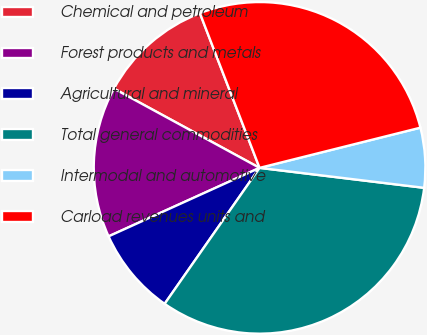Convert chart. <chart><loc_0><loc_0><loc_500><loc_500><pie_chart><fcel>Chemical and petroleum<fcel>Forest products and metals<fcel>Agricultural and mineral<fcel>Total general commodities<fcel>Intermodal and automotive<fcel>Carload revenues units and<nl><fcel>11.21%<fcel>14.71%<fcel>8.52%<fcel>32.78%<fcel>5.82%<fcel>26.96%<nl></chart> 